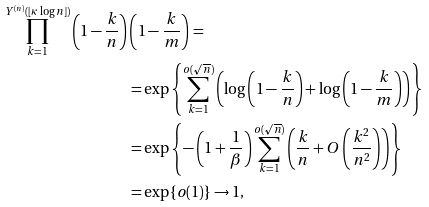Convert formula to latex. <formula><loc_0><loc_0><loc_500><loc_500>\prod _ { k = 1 } ^ { Y ^ { ( n ) } ( \lfloor \kappa \log n \rfloor ) } \left ( 1 - \frac { k } { n } \right ) & \left ( 1 - \frac { k } { m } \right ) = \\ & = \exp \left \{ \sum _ { k = 1 } ^ { o ( \sqrt { n } ) } \left ( \log \left ( 1 - \frac { k } { n } \right ) + \log \left ( 1 - \frac { k } { m } \right ) \right ) \right \} \\ & = \exp \left \{ - \left ( 1 + \frac { 1 } { \beta } \right ) \sum _ { k = 1 } ^ { o ( \sqrt { n } ) } \left ( \frac { k } { n } + O \left ( \frac { k ^ { 2 } } { n ^ { 2 } } \right ) \right ) \right \} \\ & = \exp \{ o ( 1 ) \} \to 1 ,</formula> 